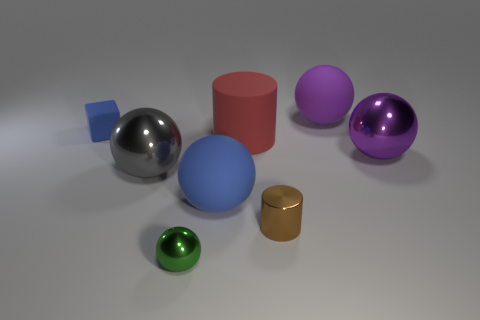Subtract all blue spheres. How many spheres are left? 4 Add 2 brown things. How many objects exist? 10 Subtract all gray balls. How many balls are left? 4 Subtract 1 balls. How many balls are left? 4 Subtract all green cylinders. Subtract all cyan spheres. How many cylinders are left? 2 Subtract all gray cylinders. How many gray spheres are left? 1 Subtract all matte spheres. Subtract all big red rubber things. How many objects are left? 5 Add 7 brown metallic objects. How many brown metallic objects are left? 8 Add 1 tiny cyan balls. How many tiny cyan balls exist? 1 Subtract 0 cyan cylinders. How many objects are left? 8 